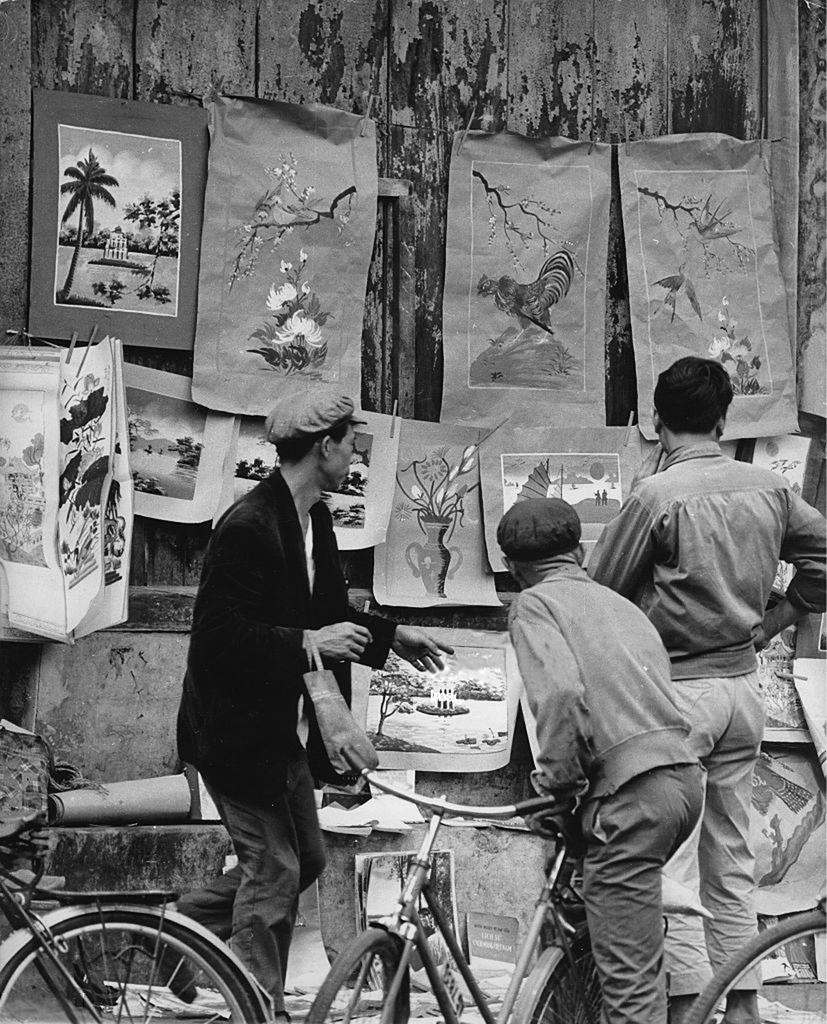How many cycles are present in the image? There are 2 cycles in the image. How many men are in the image? There are 3 men in the image. What can be seen on the wall in the image? There are arts on the wall in the image. How many kittens are playing with the snail in the image? There are no kittens or snails present in the image. 